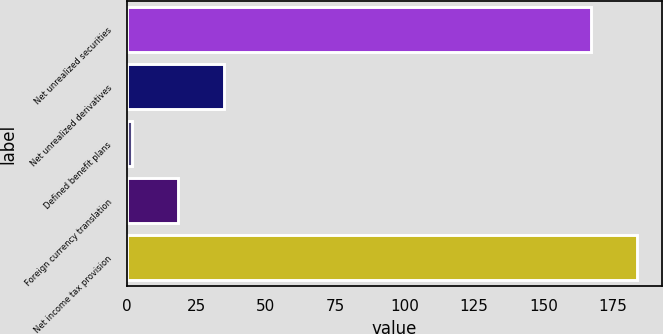Convert chart. <chart><loc_0><loc_0><loc_500><loc_500><bar_chart><fcel>Net unrealized securities<fcel>Net unrealized derivatives<fcel>Defined benefit plans<fcel>Foreign currency translation<fcel>Net income tax provision<nl><fcel>167<fcel>35<fcel>2<fcel>18.5<fcel>183.5<nl></chart> 